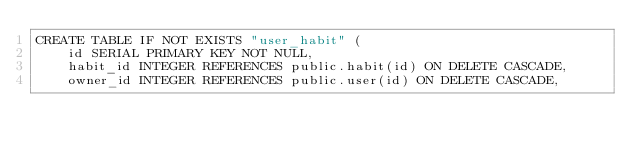<code> <loc_0><loc_0><loc_500><loc_500><_SQL_>CREATE TABLE IF NOT EXISTS "user_habit" (
    id SERIAL PRIMARY KEY NOT NULL,
    habit_id INTEGER REFERENCES public.habit(id) ON DELETE CASCADE,
    owner_id INTEGER REFERENCES public.user(id) ON DELETE CASCADE,</code> 